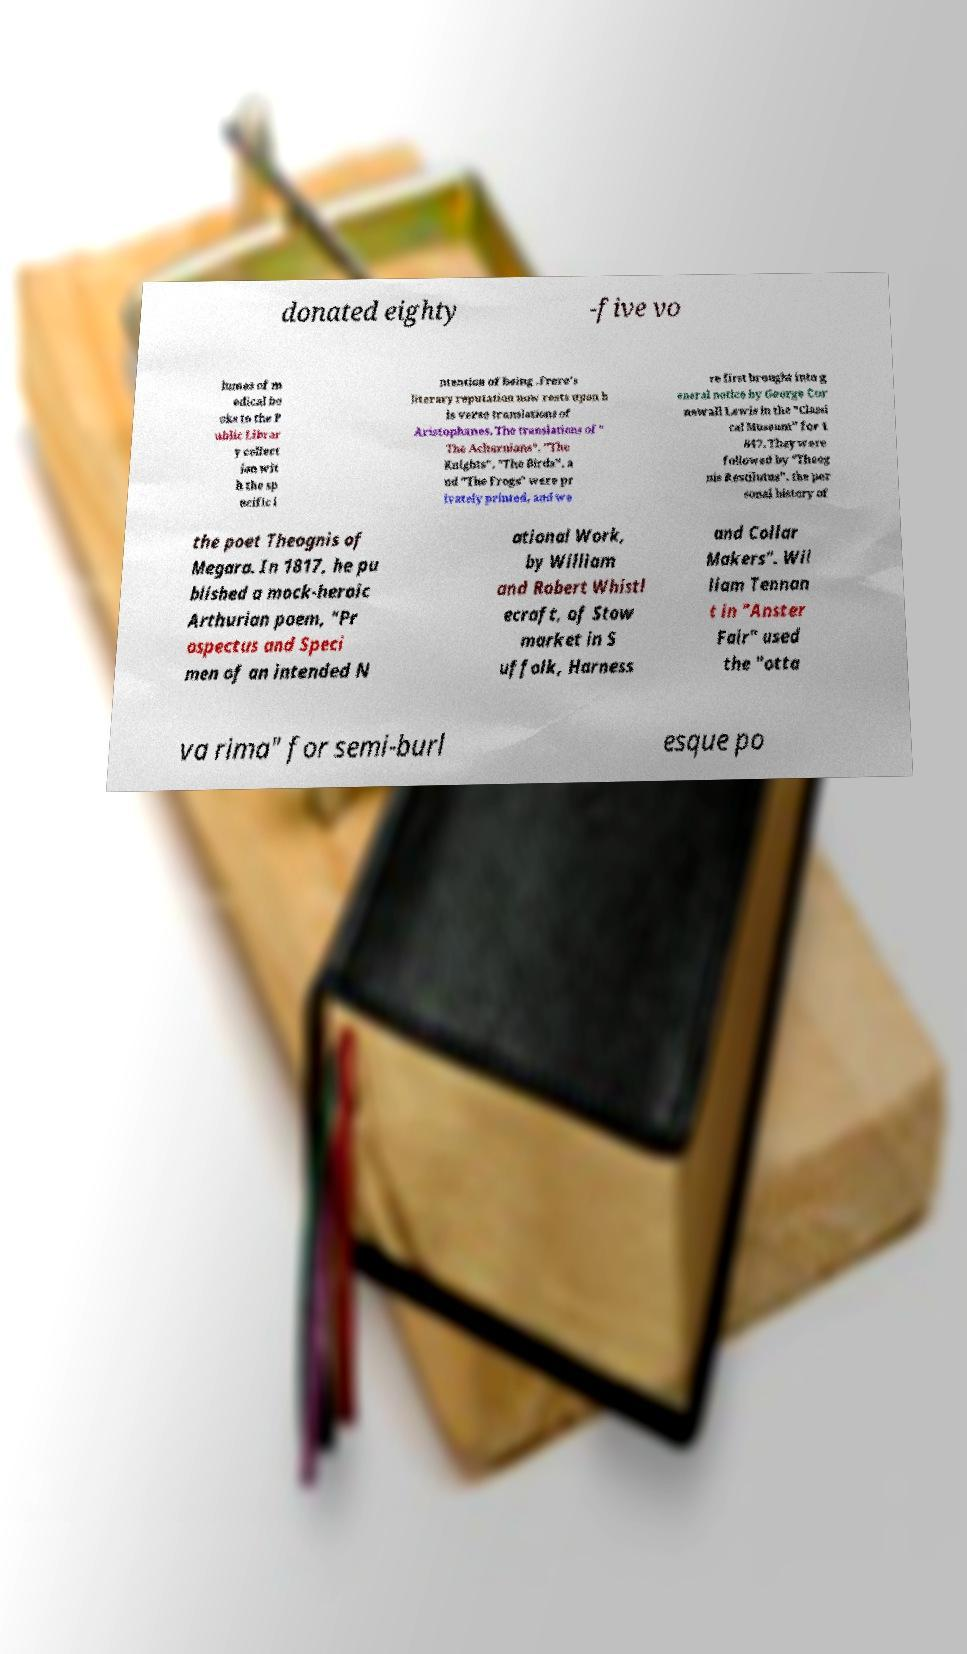I need the written content from this picture converted into text. Can you do that? donated eighty -five vo lumes of m edical bo oks to the P ublic Librar y collect ion wit h the sp ecific i ntention of being .Frere's literary reputation now rests upon h is verse translations of Aristophanes. The translations of " The Acharnians", "The Knights", "The Birds", a nd "The Frogs" were pr ivately printed, and we re first brought into g eneral notice by George Cor newall Lewis in the "Classi cal Museum" for 1 847. They were followed by "Theog nis Restilutus", the per sonal history of the poet Theognis of Megara. In 1817, he pu blished a mock-heroic Arthurian poem, "Pr ospectus and Speci men of an intended N ational Work, by William and Robert Whistl ecraft, of Stow market in S uffolk, Harness and Collar Makers". Wil liam Tennan t in "Anster Fair" used the "otta va rima" for semi-burl esque po 